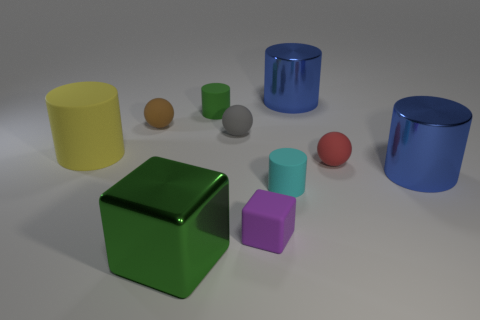Subtract all yellow cylinders. How many cylinders are left? 4 Subtract all small cyan matte cylinders. How many cylinders are left? 4 Subtract all cyan cylinders. Subtract all gray cubes. How many cylinders are left? 4 Subtract all blocks. How many objects are left? 8 Subtract 0 purple cylinders. How many objects are left? 10 Subtract all blue cubes. Subtract all blue cylinders. How many objects are left? 8 Add 4 red rubber objects. How many red rubber objects are left? 5 Add 3 large green shiny cubes. How many large green shiny cubes exist? 4 